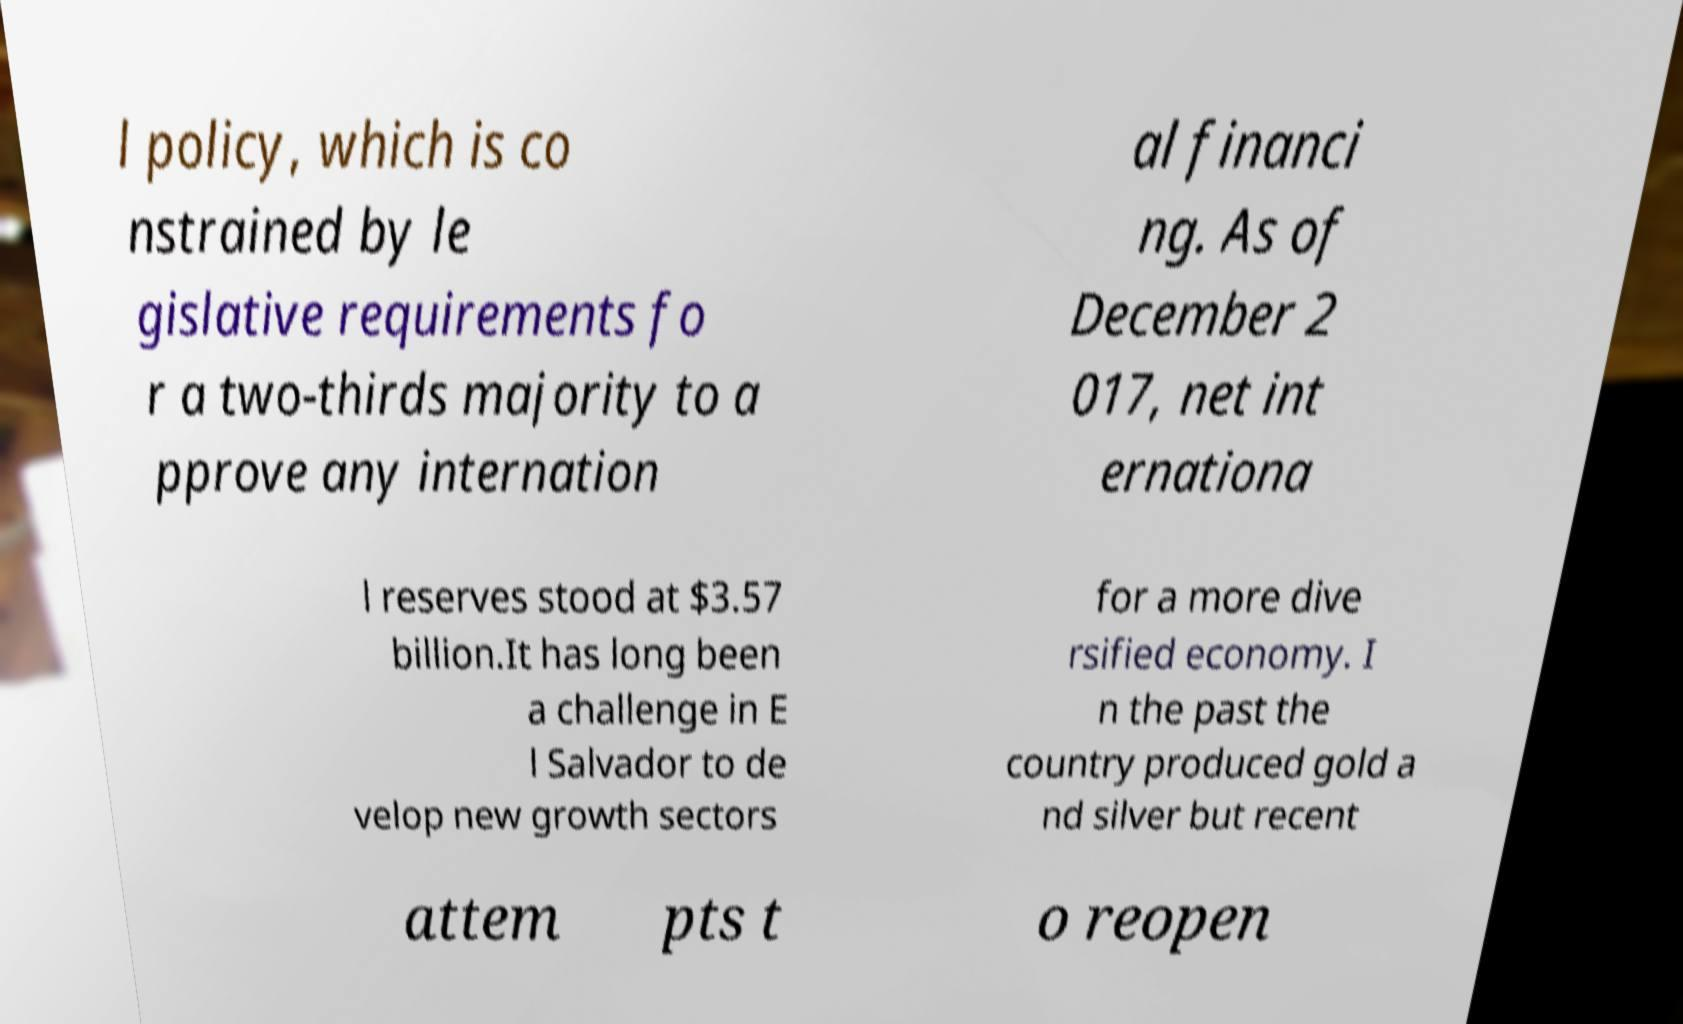For documentation purposes, I need the text within this image transcribed. Could you provide that? l policy, which is co nstrained by le gislative requirements fo r a two-thirds majority to a pprove any internation al financi ng. As of December 2 017, net int ernationa l reserves stood at $3.57 billion.It has long been a challenge in E l Salvador to de velop new growth sectors for a more dive rsified economy. I n the past the country produced gold a nd silver but recent attem pts t o reopen 